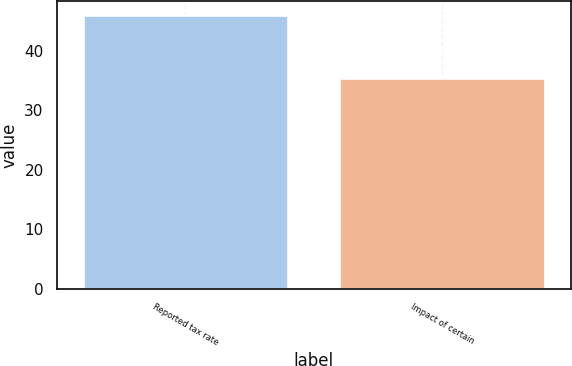<chart> <loc_0><loc_0><loc_500><loc_500><bar_chart><fcel>Reported tax rate<fcel>Impact of certain<nl><fcel>46<fcel>35.4<nl></chart> 